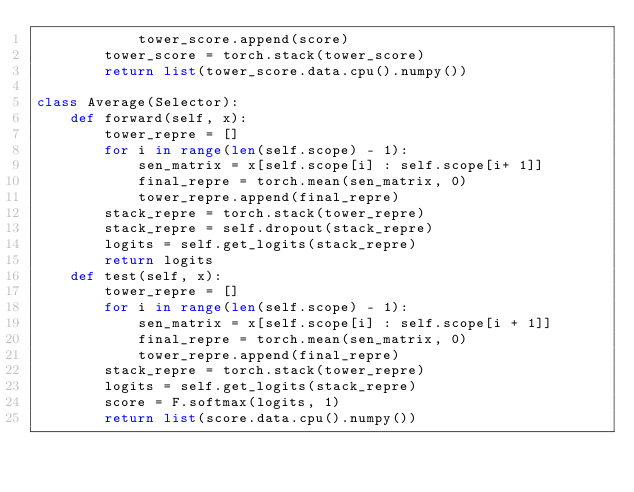<code> <loc_0><loc_0><loc_500><loc_500><_Python_>			tower_score.append(score)
		tower_score = torch.stack(tower_score)
		return list(tower_score.data.cpu().numpy())

class Average(Selector):
	def forward(self, x):
		tower_repre = []
		for i in range(len(self.scope) - 1):
			sen_matrix = x[self.scope[i] : self.scope[i+ 1]]
			final_repre = torch.mean(sen_matrix, 0)
			tower_repre.append(final_repre)
		stack_repre = torch.stack(tower_repre)
		stack_repre = self.dropout(stack_repre)
		logits = self.get_logits(stack_repre)
		return logits
	def test(self, x):
		tower_repre = []
		for i in range(len(self.scope) - 1):
			sen_matrix = x[self.scope[i] : self.scope[i + 1]]
			final_repre = torch.mean(sen_matrix, 0)
			tower_repre.append(final_repre)
		stack_repre = torch.stack(tower_repre)
		logits = self.get_logits(stack_repre)
		score = F.softmax(logits, 1)
		return list(score.data.cpu().numpy())
</code> 